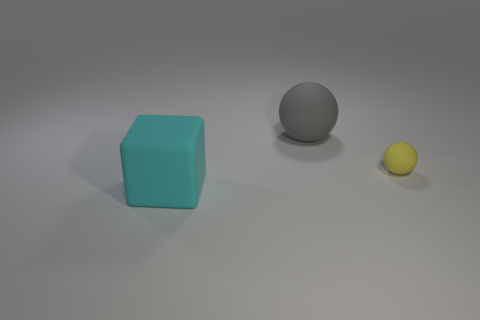Add 3 tiny cyan rubber cylinders. How many objects exist? 6 Subtract all cubes. How many objects are left? 2 Add 1 cyan shiny blocks. How many cyan shiny blocks exist? 1 Subtract 0 brown cubes. How many objects are left? 3 Subtract all small blocks. Subtract all yellow matte spheres. How many objects are left? 2 Add 3 big rubber blocks. How many big rubber blocks are left? 4 